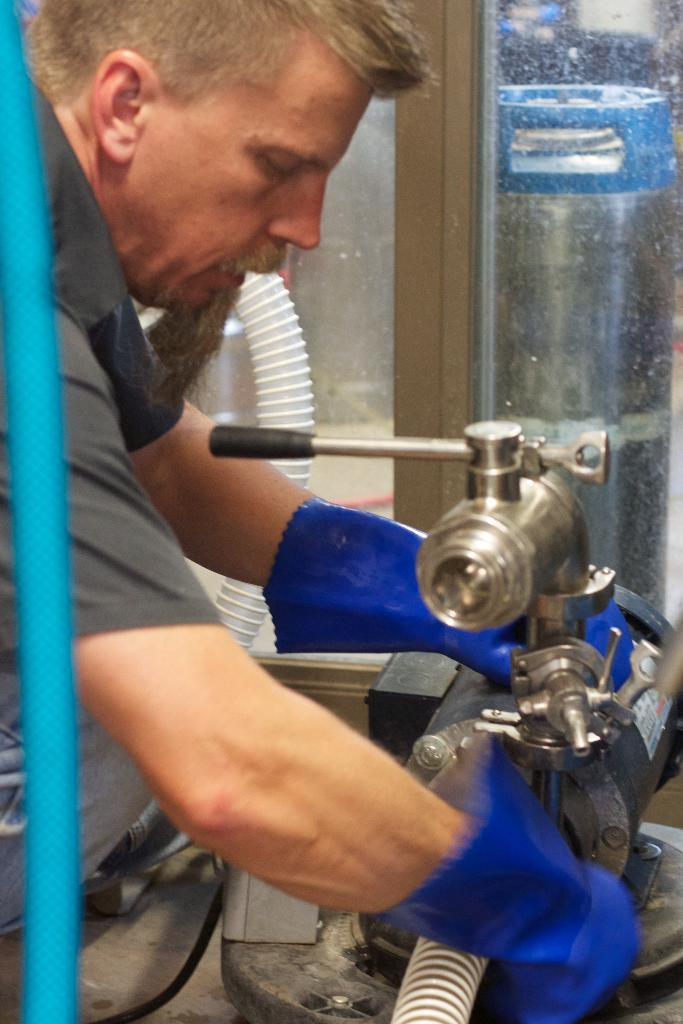What is the main subject of the image? There is a person in the center of the image. What is the person doing in the image? The person is working on a machine. Can you describe the position of the machine in relation to the person? The machine is in front of the person. What is the taste of the machine in the image? There is no taste associated with the machine in the image, as it is a physical object and not a consumable item. 